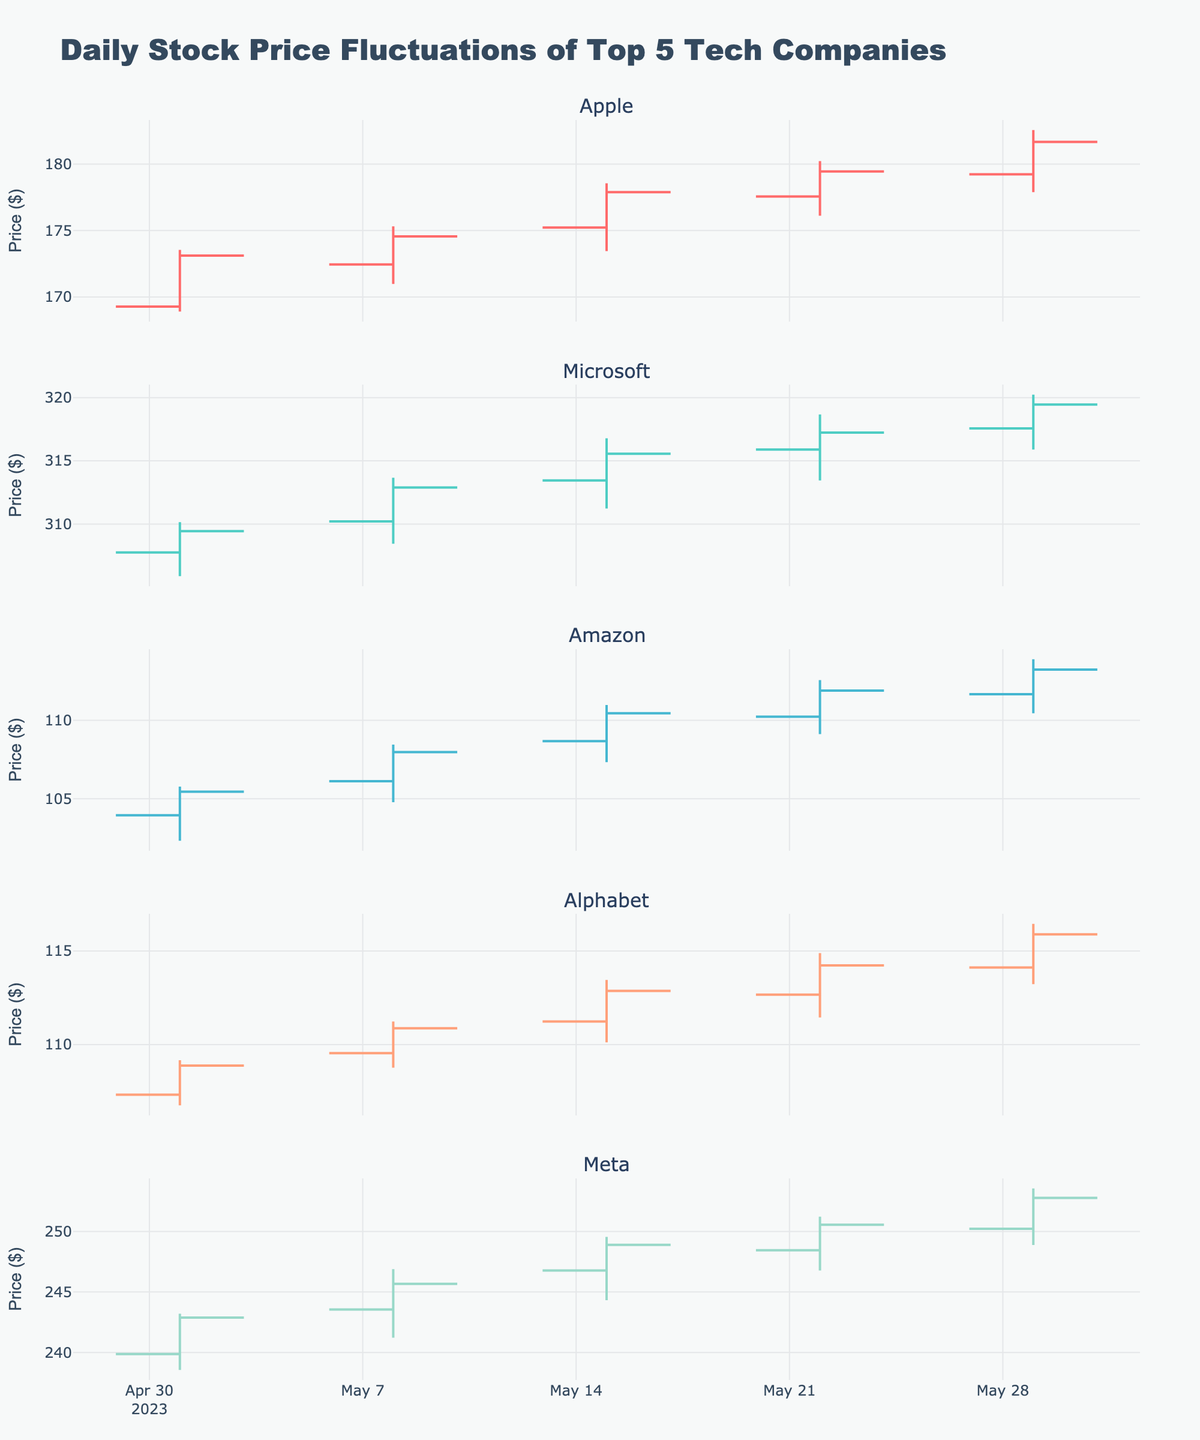What is the title of the figure? The title of the figure is located at the top and is formatted in a larger font than other text on the plot.
Answer: Daily Stock Price Fluctuations of Top 5 Tech Companies How many companies’ stock prices are visualized in the figure? There are individual subplots for each company displayed in the figure, which indicate the number of companies.
Answer: 5 Which company's stock had the highest closing price on May 29, 2023? Look at the OHLC chart for May 29, 2023, for each company and compare the 'Close' prices. Meta had the highest closing price on that date.
Answer: Meta Which company showed the greatest increase in closing price from May 1, 2023, to May 29, 2023? Calculate the difference between the closing prices on May 1 and May 29 for each company, then find the one with the greatest difference. Meta showed an increase from 242.89 to 252.78, which is the greatest increase of 9.89.
Answer: Meta What was the lowest price Alphabet's stock reached during the month? Look at Alphabet's OHLC charts and identify the lowest value in the 'Low' prices over all the days in the month. On May 1, Alphabet’s stock hit the lowest price of 106.75.
Answer: 106.75 Which company's stock has the most consistent upward trend throughout the month? By visually examining the OHLC charts for each company, identify the company whose closing prices appear to generally increase over time without significant drops. Apple shows a consistent upward trend from a close of 173.12 on May 1 to a close of 181.67 on May 29.
Answer: Apple How does the variance in the closing prices of Amazon compare to that of Microsoft over the period? To determine the variance, examine the closing prices of Amazon and Microsoft for each date and calculate the variance for each. Amazon’s closing prices (105.45, 107.98, 110.45, 111.89, 113.23) have a smaller variance compared to Microsoft's (309.44, 312.89, 315.56, 317.23, 319.45).
Answer: Amazon has a smaller variance What is the highest closing price recorded in the figure, and which company does it belong to? Look for the highest value in the 'Close' series for all companies. Meta recorded the highest closing price of 252.78 on May 29.
Answer: 252.78, Meta Did Meta or Alphabet have a larger range of prices on any single day, and on which day? The range can be identified as the high price minus the low price for each day. Compare the ranges for Meta and Alphabet across all days. On May 1, Meta had a range of 4.65 (243.21 - 238.56), whereas Alphabet had a range of 2.41 (109.16 - 106.75). Meta had the larger range on that day.
Answer: Meta, May 1 Which day had the smallest fluctuation (difference between high and low) for Apple's stock? Check the difference between the 'High' and 'Low' prices for each date in Apple's OHLC chart and find the smallest value. On May 1, the fluctuation was 4.63 (173.54 - 168.91), which was the smallest.
Answer: May 1 